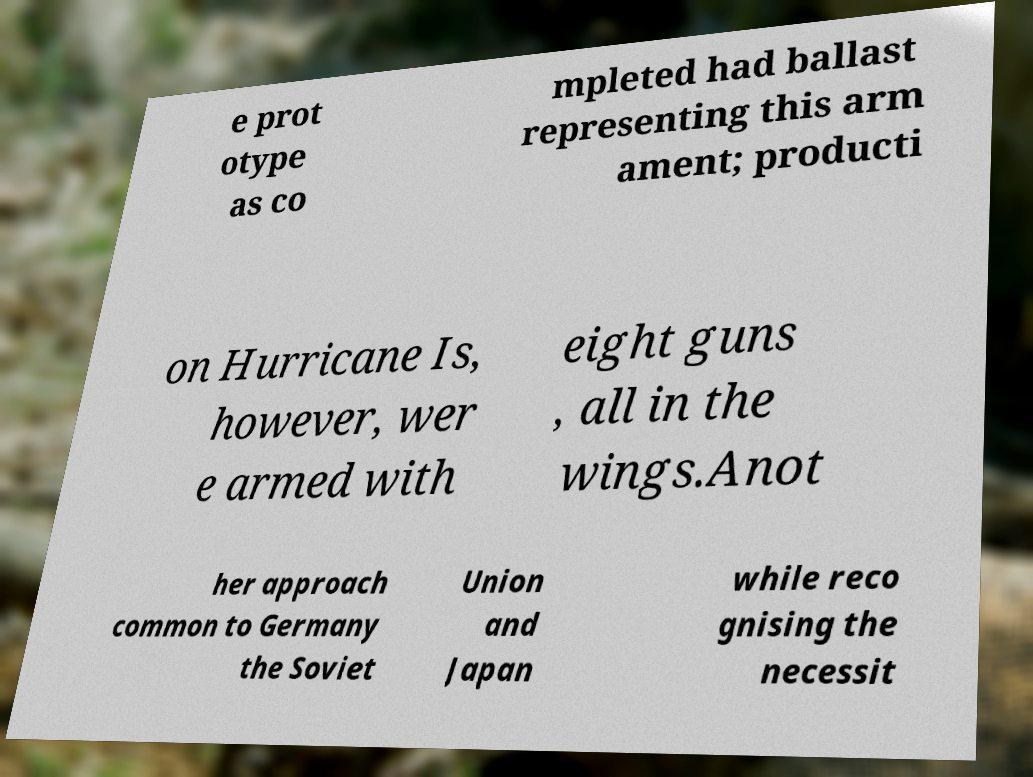There's text embedded in this image that I need extracted. Can you transcribe it verbatim? e prot otype as co mpleted had ballast representing this arm ament; producti on Hurricane Is, however, wer e armed with eight guns , all in the wings.Anot her approach common to Germany the Soviet Union and Japan while reco gnising the necessit 